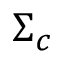Convert formula to latex. <formula><loc_0><loc_0><loc_500><loc_500>\Sigma _ { c }</formula> 